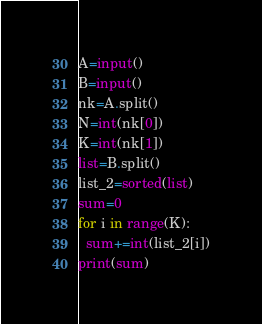<code> <loc_0><loc_0><loc_500><loc_500><_Python_>A=input()
B=input()
nk=A.split()
N=int(nk[0])
K=int(nk[1])
list=B.split()
list_2=sorted(list)
sum=0
for i in range(K):
  sum+=int(list_2[i])
print(sum)</code> 